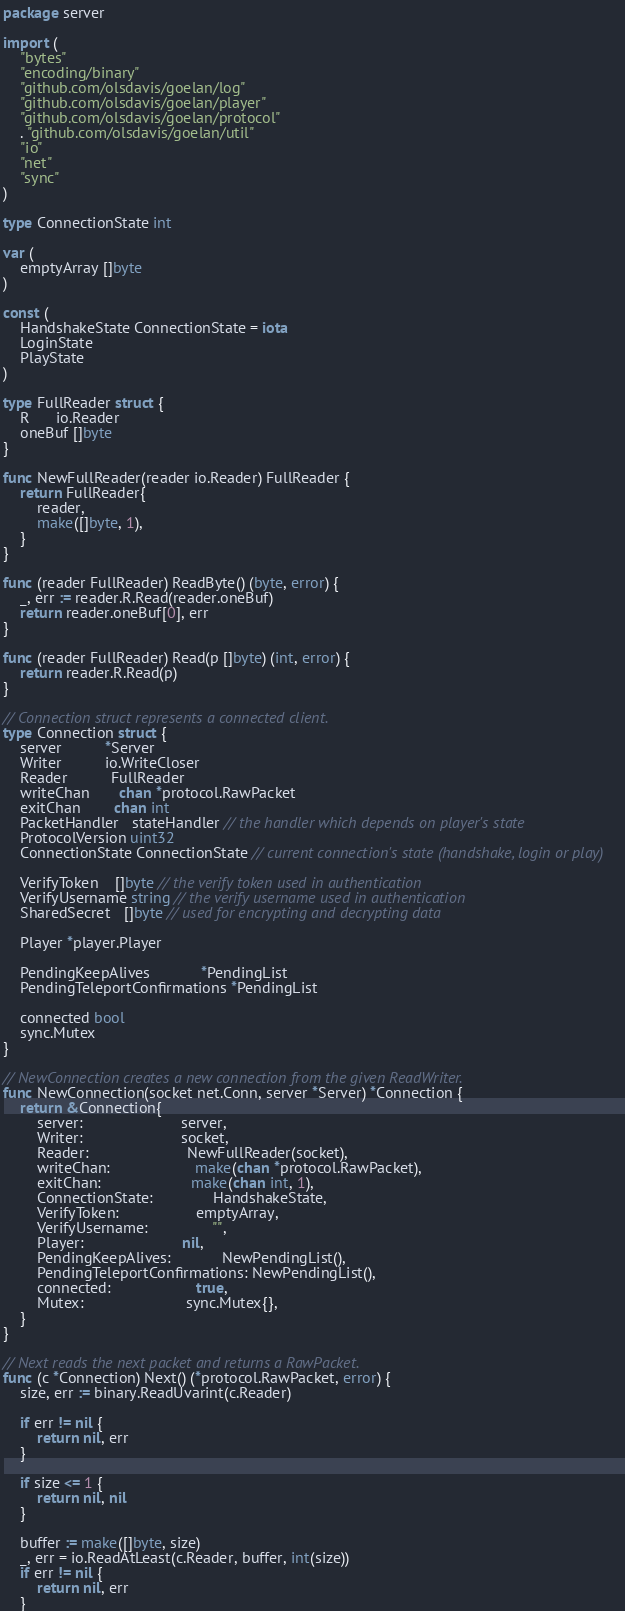<code> <loc_0><loc_0><loc_500><loc_500><_Go_>package server

import (
	"bytes"
	"encoding/binary"
	"github.com/olsdavis/goelan/log"
	"github.com/olsdavis/goelan/player"
	"github.com/olsdavis/goelan/protocol"
	. "github.com/olsdavis/goelan/util"
	"io"
	"net"
	"sync"
)

type ConnectionState int

var (
	emptyArray []byte
)

const (
	HandshakeState ConnectionState = iota
	LoginState
	PlayState
)

type FullReader struct {
	R      io.Reader
	oneBuf []byte
}

func NewFullReader(reader io.Reader) FullReader {
	return FullReader{
		reader,
		make([]byte, 1),
	}
}

func (reader FullReader) ReadByte() (byte, error) {
	_, err := reader.R.Read(reader.oneBuf)
	return reader.oneBuf[0], err
}

func (reader FullReader) Read(p []byte) (int, error) {
	return reader.R.Read(p)
}

// Connection struct represents a connected client.
type Connection struct {
	server          *Server
	Writer          io.WriteCloser
	Reader          FullReader
	writeChan       chan *protocol.RawPacket
	exitChan        chan int
	PacketHandler   stateHandler // the handler which depends on player's state
	ProtocolVersion uint32
	ConnectionState ConnectionState // current connection's state (handshake, login or play)

	VerifyToken    []byte // the verify token used in authentication
	VerifyUsername string // the verify username used in authentication
	SharedSecret   []byte // used for encrypting and decrypting data

	Player *player.Player

	PendingKeepAlives            *PendingList
	PendingTeleportConfirmations *PendingList

	connected bool
	sync.Mutex
}

// NewConnection creates a new connection from the given ReadWriter.
func NewConnection(socket net.Conn, server *Server) *Connection {
	return &Connection{
		server:                       server,
		Writer:                       socket,
		Reader:                       NewFullReader(socket),
		writeChan:                    make(chan *protocol.RawPacket),
		exitChan:                     make(chan int, 1),
		ConnectionState:              HandshakeState,
		VerifyToken:                  emptyArray,
		VerifyUsername:               "",
		Player:                       nil,
		PendingKeepAlives:            NewPendingList(),
		PendingTeleportConfirmations: NewPendingList(),
		connected:                    true,
		Mutex:                        sync.Mutex{},
	}
}

// Next reads the next packet and returns a RawPacket.
func (c *Connection) Next() (*protocol.RawPacket, error) {
	size, err := binary.ReadUvarint(c.Reader)

	if err != nil {
		return nil, err
	}

	if size <= 1 {
		return nil, nil
	}

	buffer := make([]byte, size)
	_, err = io.ReadAtLeast(c.Reader, buffer, int(size))
	if err != nil {
		return nil, err
	}</code> 